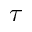Convert formula to latex. <formula><loc_0><loc_0><loc_500><loc_500>\tau</formula> 